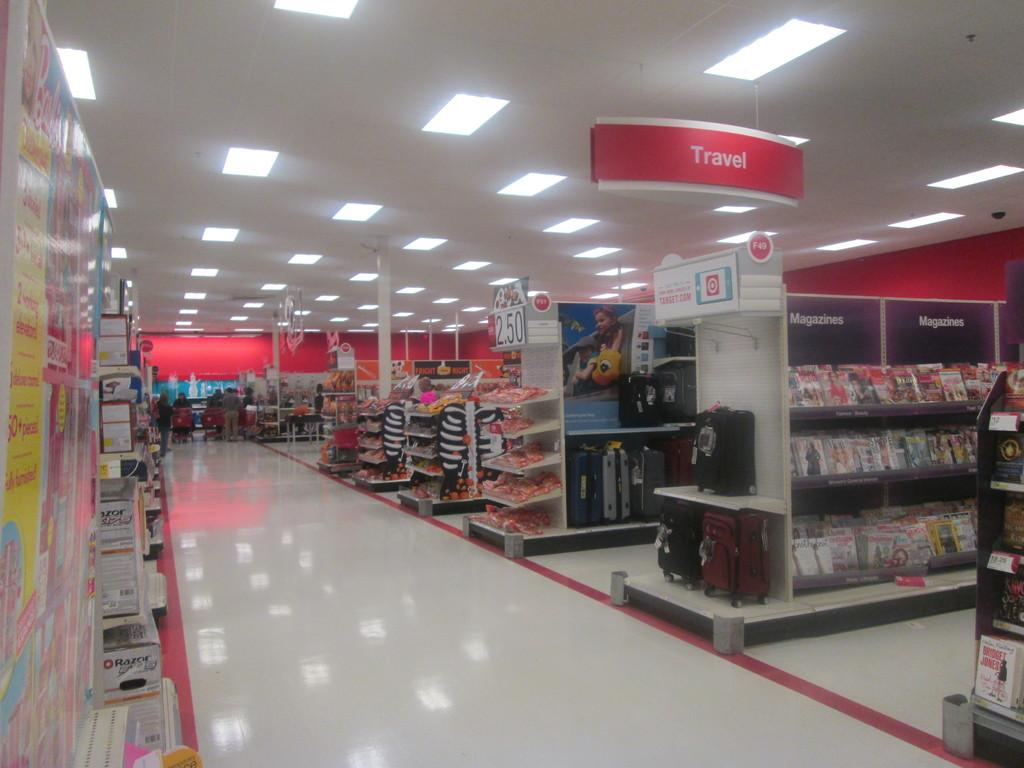<image>
Present a compact description of the photo's key features. Empty aisle of a store and a sign for the travel department. 